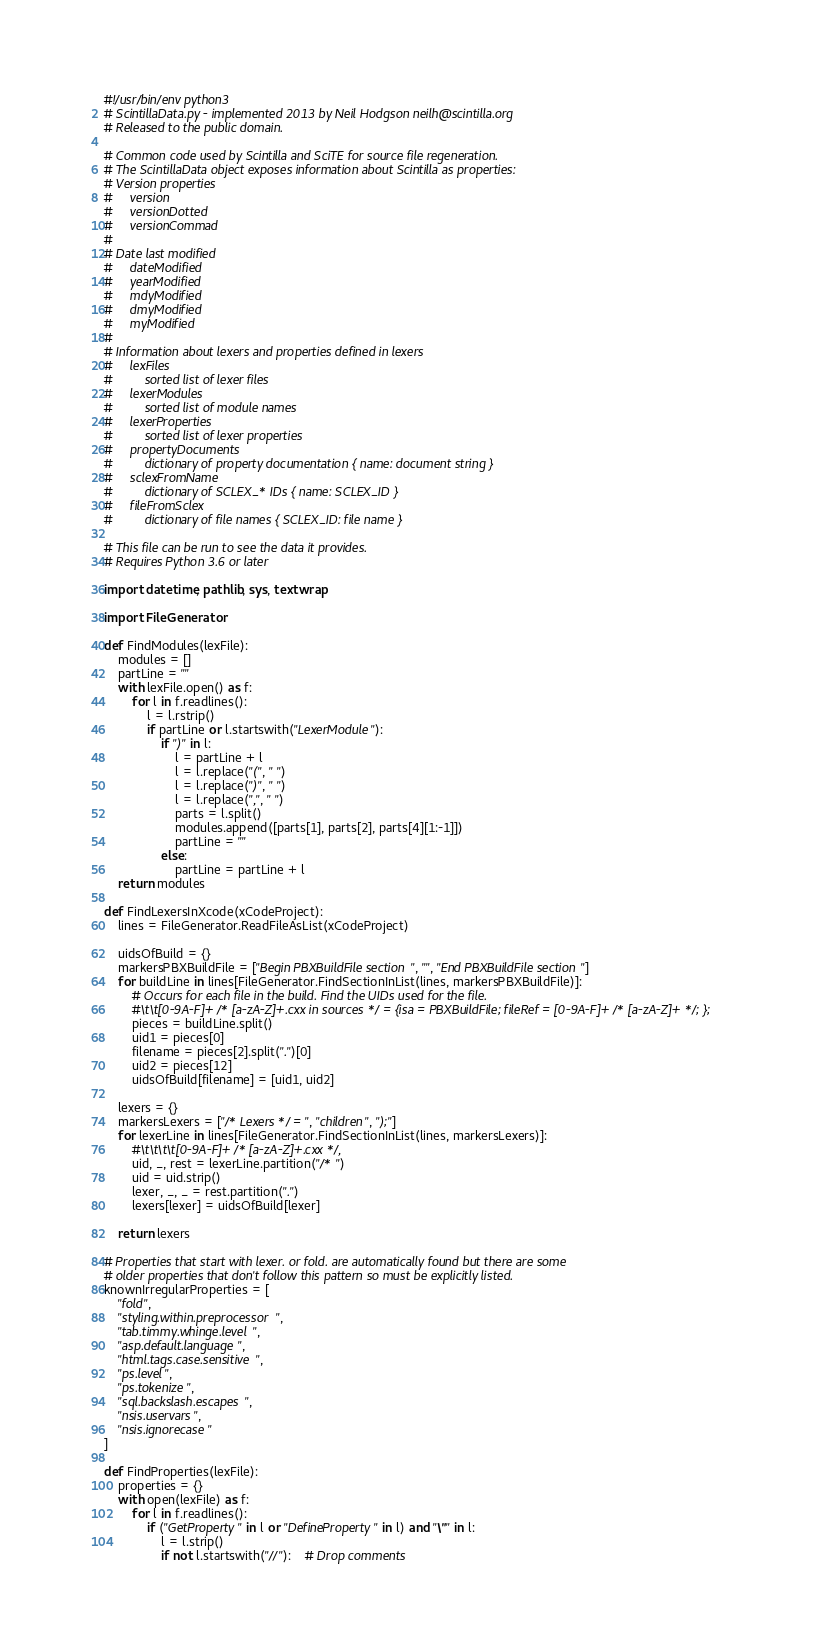Convert code to text. <code><loc_0><loc_0><loc_500><loc_500><_Python_>#!/usr/bin/env python3
# ScintillaData.py - implemented 2013 by Neil Hodgson neilh@scintilla.org
# Released to the public domain.

# Common code used by Scintilla and SciTE for source file regeneration.
# The ScintillaData object exposes information about Scintilla as properties:
# Version properties
#     version
#     versionDotted
#     versionCommad
#
# Date last modified
#     dateModified
#     yearModified
#     mdyModified
#     dmyModified
#     myModified
#
# Information about lexers and properties defined in lexers
#     lexFiles
#         sorted list of lexer files
#     lexerModules
#         sorted list of module names
#     lexerProperties
#         sorted list of lexer properties
#     propertyDocuments
#         dictionary of property documentation { name: document string }
#     sclexFromName
#         dictionary of SCLEX_* IDs { name: SCLEX_ID }
#     fileFromSclex
#         dictionary of file names { SCLEX_ID: file name }

# This file can be run to see the data it provides.
# Requires Python 3.6 or later

import datetime, pathlib, sys, textwrap

import FileGenerator

def FindModules(lexFile):
    modules = []
    partLine = ""
    with lexFile.open() as f:
        for l in f.readlines():
            l = l.rstrip()
            if partLine or l.startswith("LexerModule"):
                if ")" in l:
                    l = partLine + l
                    l = l.replace("(", " ")
                    l = l.replace(")", " ")
                    l = l.replace(",", " ")
                    parts = l.split()
                    modules.append([parts[1], parts[2], parts[4][1:-1]])
                    partLine = ""
                else:
                    partLine = partLine + l
    return modules

def FindLexersInXcode(xCodeProject):
    lines = FileGenerator.ReadFileAsList(xCodeProject)

    uidsOfBuild = {}
    markersPBXBuildFile = ["Begin PBXBuildFile section", "", "End PBXBuildFile section"]
    for buildLine in lines[FileGenerator.FindSectionInList(lines, markersPBXBuildFile)]:
        # Occurs for each file in the build. Find the UIDs used for the file.
        #\t\t[0-9A-F]+ /* [a-zA-Z]+.cxx in sources */ = {isa = PBXBuildFile; fileRef = [0-9A-F]+ /* [a-zA-Z]+ */; };
        pieces = buildLine.split()
        uid1 = pieces[0]
        filename = pieces[2].split(".")[0]
        uid2 = pieces[12]
        uidsOfBuild[filename] = [uid1, uid2]

    lexers = {}
    markersLexers = ["/* Lexers */ =", "children", ");"]
    for lexerLine in lines[FileGenerator.FindSectionInList(lines, markersLexers)]:
        #\t\t\t\t[0-9A-F]+ /* [a-zA-Z]+.cxx */,
        uid, _, rest = lexerLine.partition("/* ")
        uid = uid.strip()
        lexer, _, _ = rest.partition(".")
        lexers[lexer] = uidsOfBuild[lexer]

    return lexers

# Properties that start with lexer. or fold. are automatically found but there are some
# older properties that don't follow this pattern so must be explicitly listed.
knownIrregularProperties = [
    "fold",
    "styling.within.preprocessor",
    "tab.timmy.whinge.level",
    "asp.default.language",
    "html.tags.case.sensitive",
    "ps.level",
    "ps.tokenize",
    "sql.backslash.escapes",
    "nsis.uservars",
    "nsis.ignorecase"
]

def FindProperties(lexFile):
    properties = {}
    with open(lexFile) as f:
        for l in f.readlines():
            if ("GetProperty" in l or "DefineProperty" in l) and "\"" in l:
                l = l.strip()
                if not l.startswith("//"):	# Drop comments</code> 